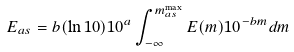Convert formula to latex. <formula><loc_0><loc_0><loc_500><loc_500>E _ { a s } = b ( \ln 1 0 ) 1 0 ^ { a } \int _ { - \infty } ^ { m _ { a s } ^ { \max } } E ( m ) 1 0 ^ { - b m } d m</formula> 